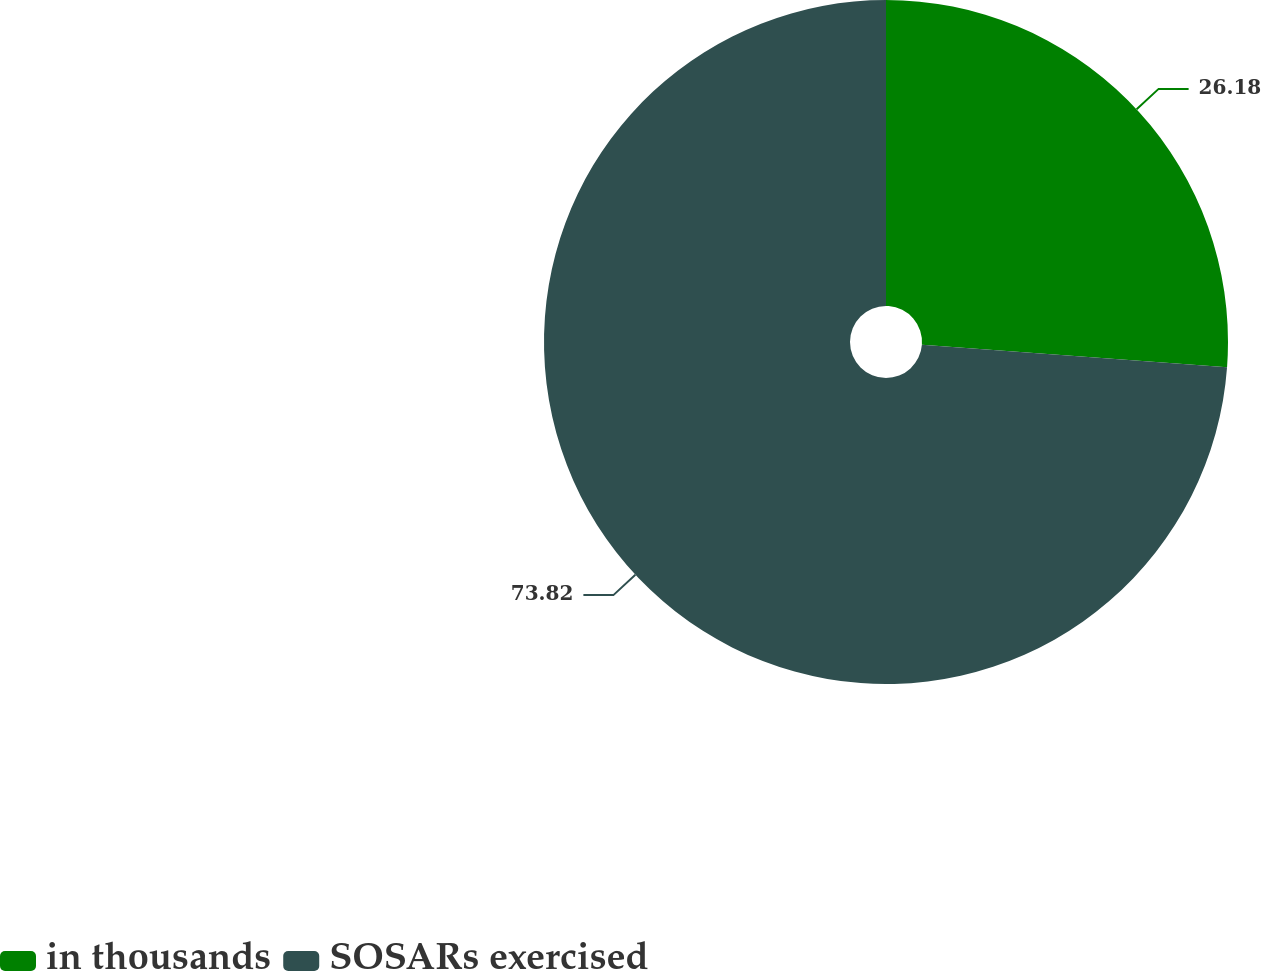Convert chart to OTSL. <chart><loc_0><loc_0><loc_500><loc_500><pie_chart><fcel>in thousands<fcel>SOSARs exercised<nl><fcel>26.18%<fcel>73.82%<nl></chart> 